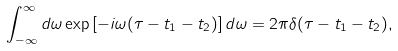Convert formula to latex. <formula><loc_0><loc_0><loc_500><loc_500>\int _ { - \infty } ^ { \infty } d \omega \exp \left [ - i \omega ( \tau - t _ { 1 } - t _ { 2 } ) \right ] d \omega = 2 \pi \delta ( \tau - t _ { 1 } - t _ { 2 } ) ,</formula> 